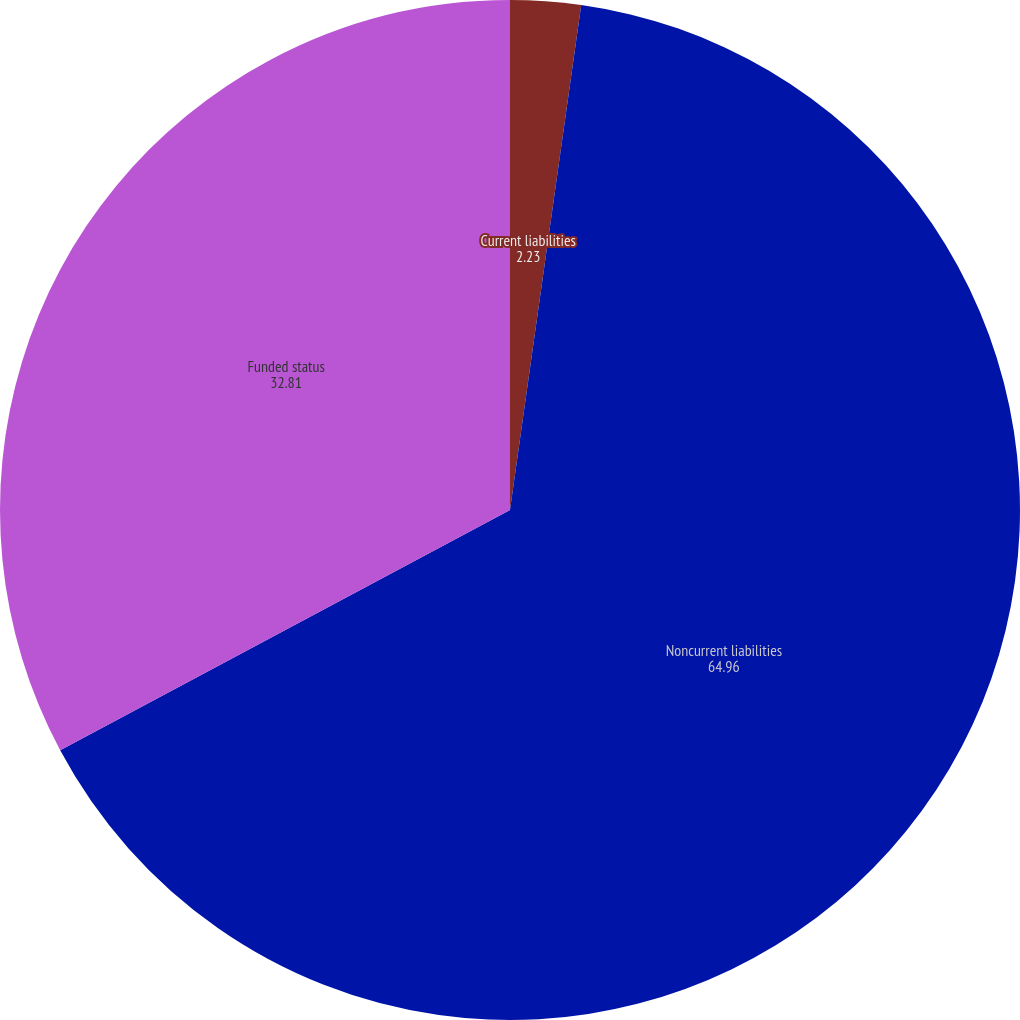Convert chart. <chart><loc_0><loc_0><loc_500><loc_500><pie_chart><fcel>Current liabilities<fcel>Noncurrent liabilities<fcel>Funded status<nl><fcel>2.23%<fcel>64.96%<fcel>32.81%<nl></chart> 